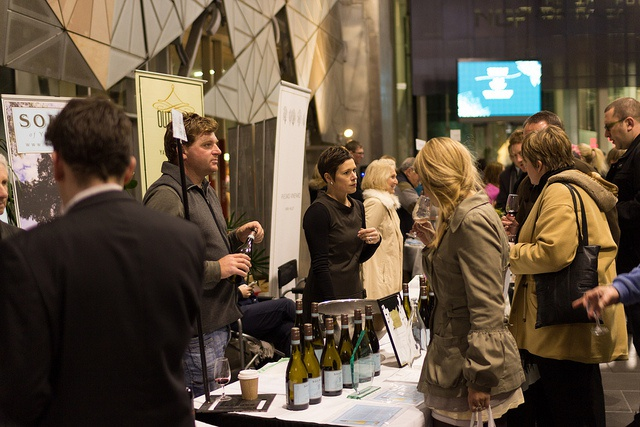Describe the objects in this image and their specific colors. I can see people in gray, black, and maroon tones, people in gray, black, maroon, and tan tones, people in gray, black, and maroon tones, dining table in gray, lightgray, black, darkgray, and olive tones, and people in gray, black, and maroon tones in this image. 